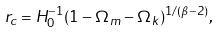Convert formula to latex. <formula><loc_0><loc_0><loc_500><loc_500>r _ { c } = H _ { 0 } ^ { - 1 } ( 1 - \Omega _ { m } - \Omega _ { k } ) ^ { 1 / ( \beta - 2 ) } ,</formula> 